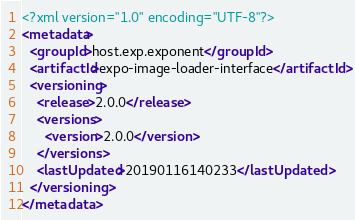Convert code to text. <code><loc_0><loc_0><loc_500><loc_500><_XML_><?xml version="1.0" encoding="UTF-8"?>
<metadata>
  <groupId>host.exp.exponent</groupId>
  <artifactId>expo-image-loader-interface</artifactId>
  <versioning>
    <release>2.0.0</release>
    <versions>
      <version>2.0.0</version>
    </versions>
    <lastUpdated>20190116140233</lastUpdated>
  </versioning>
</metadata>
</code> 